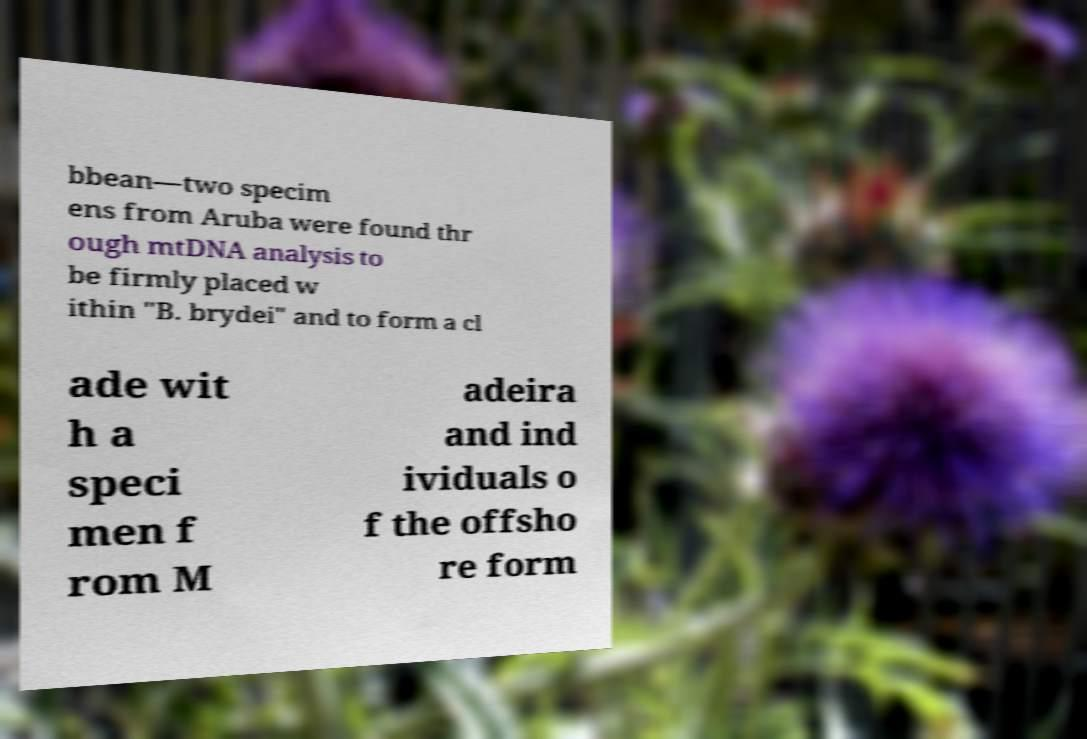Can you accurately transcribe the text from the provided image for me? bbean—two specim ens from Aruba were found thr ough mtDNA analysis to be firmly placed w ithin "B. brydei" and to form a cl ade wit h a speci men f rom M adeira and ind ividuals o f the offsho re form 